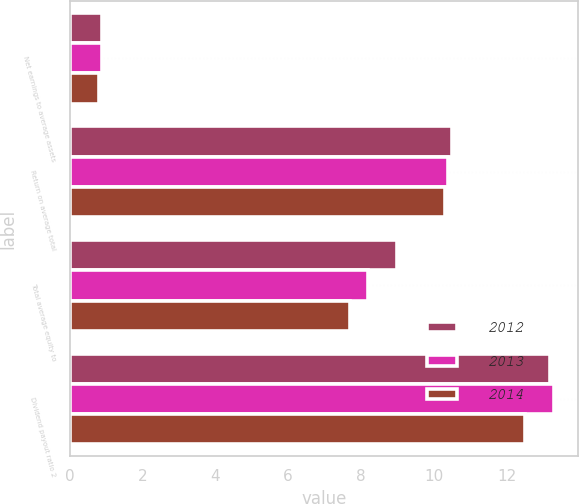Convert chart. <chart><loc_0><loc_0><loc_500><loc_500><stacked_bar_chart><ecel><fcel>Net earnings to average assets<fcel>Return on average total<fcel>Total average equity to<fcel>Dividend payout ratio 2<nl><fcel>2012<fcel>0.9<fcel>10.5<fcel>9<fcel>13.2<nl><fcel>2013<fcel>0.9<fcel>10.4<fcel>8.2<fcel>13.3<nl><fcel>2014<fcel>0.8<fcel>10.3<fcel>7.7<fcel>12.5<nl></chart> 